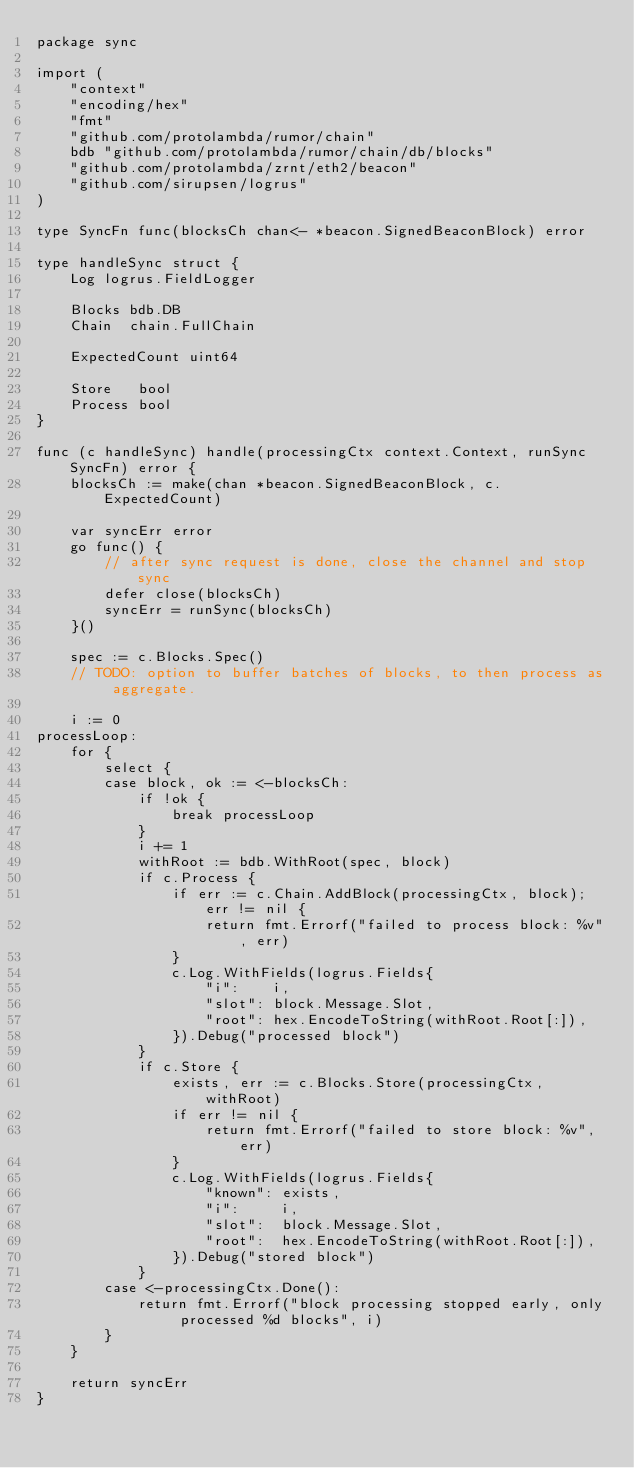<code> <loc_0><loc_0><loc_500><loc_500><_Go_>package sync

import (
	"context"
	"encoding/hex"
	"fmt"
	"github.com/protolambda/rumor/chain"
	bdb "github.com/protolambda/rumor/chain/db/blocks"
	"github.com/protolambda/zrnt/eth2/beacon"
	"github.com/sirupsen/logrus"
)

type SyncFn func(blocksCh chan<- *beacon.SignedBeaconBlock) error

type handleSync struct {
	Log logrus.FieldLogger

	Blocks bdb.DB
	Chain  chain.FullChain

	ExpectedCount uint64

	Store   bool
	Process bool
}

func (c handleSync) handle(processingCtx context.Context, runSync SyncFn) error {
	blocksCh := make(chan *beacon.SignedBeaconBlock, c.ExpectedCount)

	var syncErr error
	go func() {
		// after sync request is done, close the channel and stop sync
		defer close(blocksCh)
		syncErr = runSync(blocksCh)
	}()

	spec := c.Blocks.Spec()
	// TODO: option to buffer batches of blocks, to then process as aggregate.

	i := 0
processLoop:
	for {
		select {
		case block, ok := <-blocksCh:
			if !ok {
				break processLoop
			}
			i += 1
			withRoot := bdb.WithRoot(spec, block)
			if c.Process {
				if err := c.Chain.AddBlock(processingCtx, block); err != nil {
					return fmt.Errorf("failed to process block: %v", err)
				}
				c.Log.WithFields(logrus.Fields{
					"i":    i,
					"slot": block.Message.Slot,
					"root": hex.EncodeToString(withRoot.Root[:]),
				}).Debug("processed block")
			}
			if c.Store {
				exists, err := c.Blocks.Store(processingCtx, withRoot)
				if err != nil {
					return fmt.Errorf("failed to store block: %v", err)
				}
				c.Log.WithFields(logrus.Fields{
					"known": exists,
					"i":     i,
					"slot":  block.Message.Slot,
					"root":  hex.EncodeToString(withRoot.Root[:]),
				}).Debug("stored block")
			}
		case <-processingCtx.Done():
			return fmt.Errorf("block processing stopped early, only processed %d blocks", i)
		}
	}

	return syncErr
}
</code> 